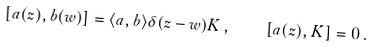Convert formula to latex. <formula><loc_0><loc_0><loc_500><loc_500>[ a ( z ) , b ( w ) ] = \langle a , b \rangle \delta ( z - w ) K \, , \quad [ a ( z ) , K ] = 0 \, .</formula> 